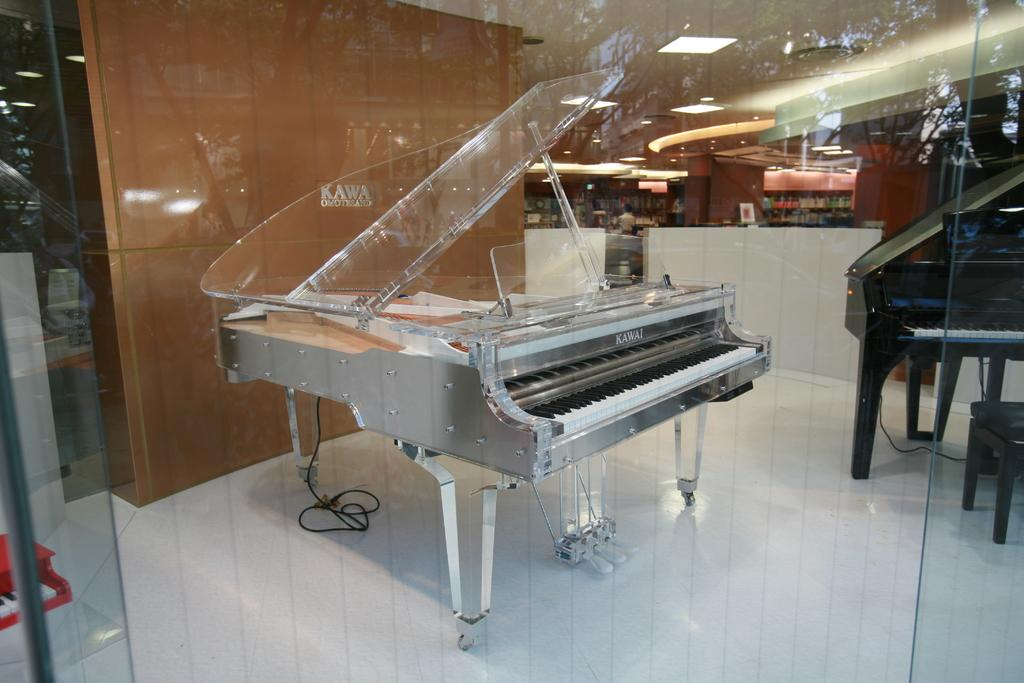How many pianos are present in the image? There are two pianos in the image. What are the colors of the pianos? One piano is white in color, and the other is black in color. What can be seen on the wall in the image? There is a brown color wall in the image. How many twigs are arranged in a circle on the floor in the image? There are no twigs or circles present in the image. 